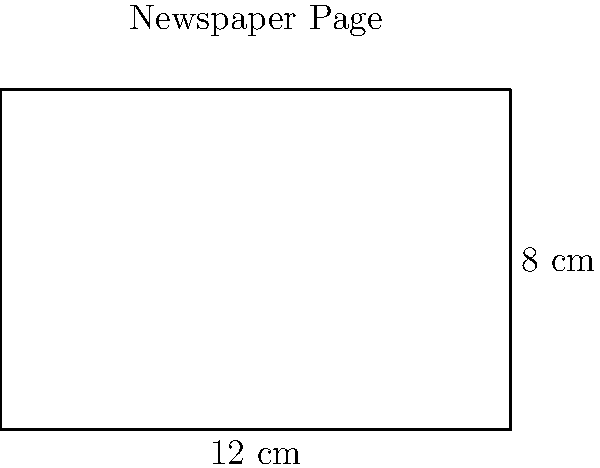As a seasoned journalist, you're reminiscing about your old newspaper days. You recall a standard page from your former publication measured 12 cm in width and 8 cm in height. What was the perimeter of this rectangular page? To calculate the perimeter of a rectangular page, we need to add up the lengths of all four sides. Let's break it down step-by-step:

1. Identify the dimensions:
   - Width = 12 cm
   - Height = 8 cm

2. Recall the formula for the perimeter of a rectangle:
   $$ \text{Perimeter} = 2 \times (\text{width} + \text{height}) $$

3. Substitute the values into the formula:
   $$ \text{Perimeter} = 2 \times (12 \text{ cm} + 8 \text{ cm}) $$

4. Calculate the sum inside the parentheses:
   $$ \text{Perimeter} = 2 \times (20 \text{ cm}) $$

5. Multiply:
   $$ \text{Perimeter} = 40 \text{ cm} $$

Therefore, the perimeter of the newspaper page is 40 cm.
Answer: 40 cm 